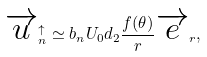<formula> <loc_0><loc_0><loc_500><loc_500>\overrightarrow { u } _ { n } ^ { \uparrow } \simeq b _ { n } U _ { 0 } d _ { 2 } \frac { f ( \theta ) } { r } \overrightarrow { e } _ { r } ,</formula> 